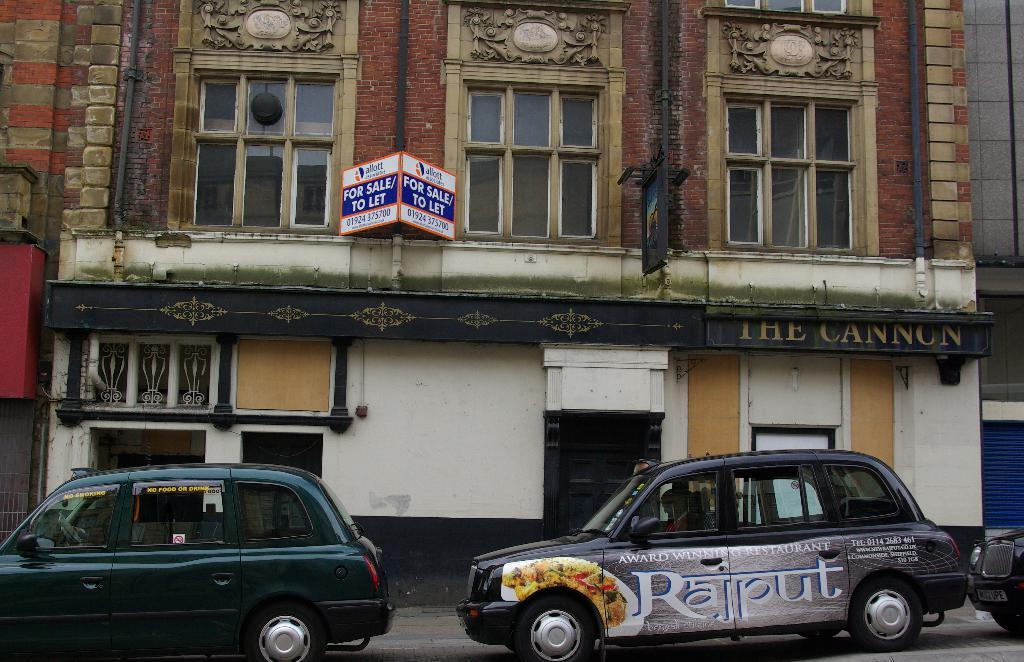<image>
Give a short and clear explanation of the subsequent image. The streetside view of The Cannon, with two cars in front of it. 